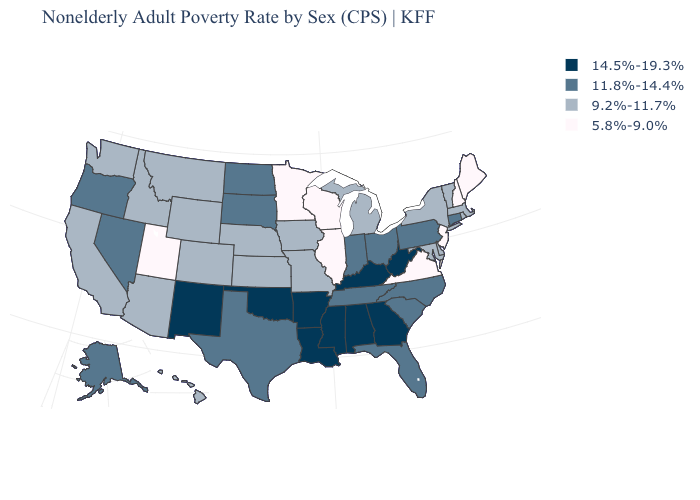What is the value of New Jersey?
Be succinct. 5.8%-9.0%. What is the value of Iowa?
Keep it brief. 9.2%-11.7%. Among the states that border Wyoming , does Utah have the lowest value?
Write a very short answer. Yes. What is the value of Maryland?
Concise answer only. 9.2%-11.7%. What is the lowest value in the USA?
Concise answer only. 5.8%-9.0%. What is the lowest value in the Northeast?
Quick response, please. 5.8%-9.0%. Which states have the lowest value in the South?
Concise answer only. Virginia. Does Nebraska have a lower value than Maryland?
Answer briefly. No. Among the states that border Missouri , which have the highest value?
Give a very brief answer. Arkansas, Kentucky, Oklahoma. Does Minnesota have the highest value in the MidWest?
Quick response, please. No. Name the states that have a value in the range 11.8%-14.4%?
Give a very brief answer. Alaska, Connecticut, Florida, Indiana, Nevada, North Carolina, North Dakota, Ohio, Oregon, Pennsylvania, South Carolina, South Dakota, Tennessee, Texas. What is the value of Ohio?
Write a very short answer. 11.8%-14.4%. What is the lowest value in states that border South Carolina?
Keep it brief. 11.8%-14.4%. Which states have the highest value in the USA?
Concise answer only. Alabama, Arkansas, Georgia, Kentucky, Louisiana, Mississippi, New Mexico, Oklahoma, West Virginia. Among the states that border Connecticut , which have the highest value?
Short answer required. Massachusetts, New York, Rhode Island. 